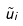<formula> <loc_0><loc_0><loc_500><loc_500>\tilde { u } _ { i }</formula> 